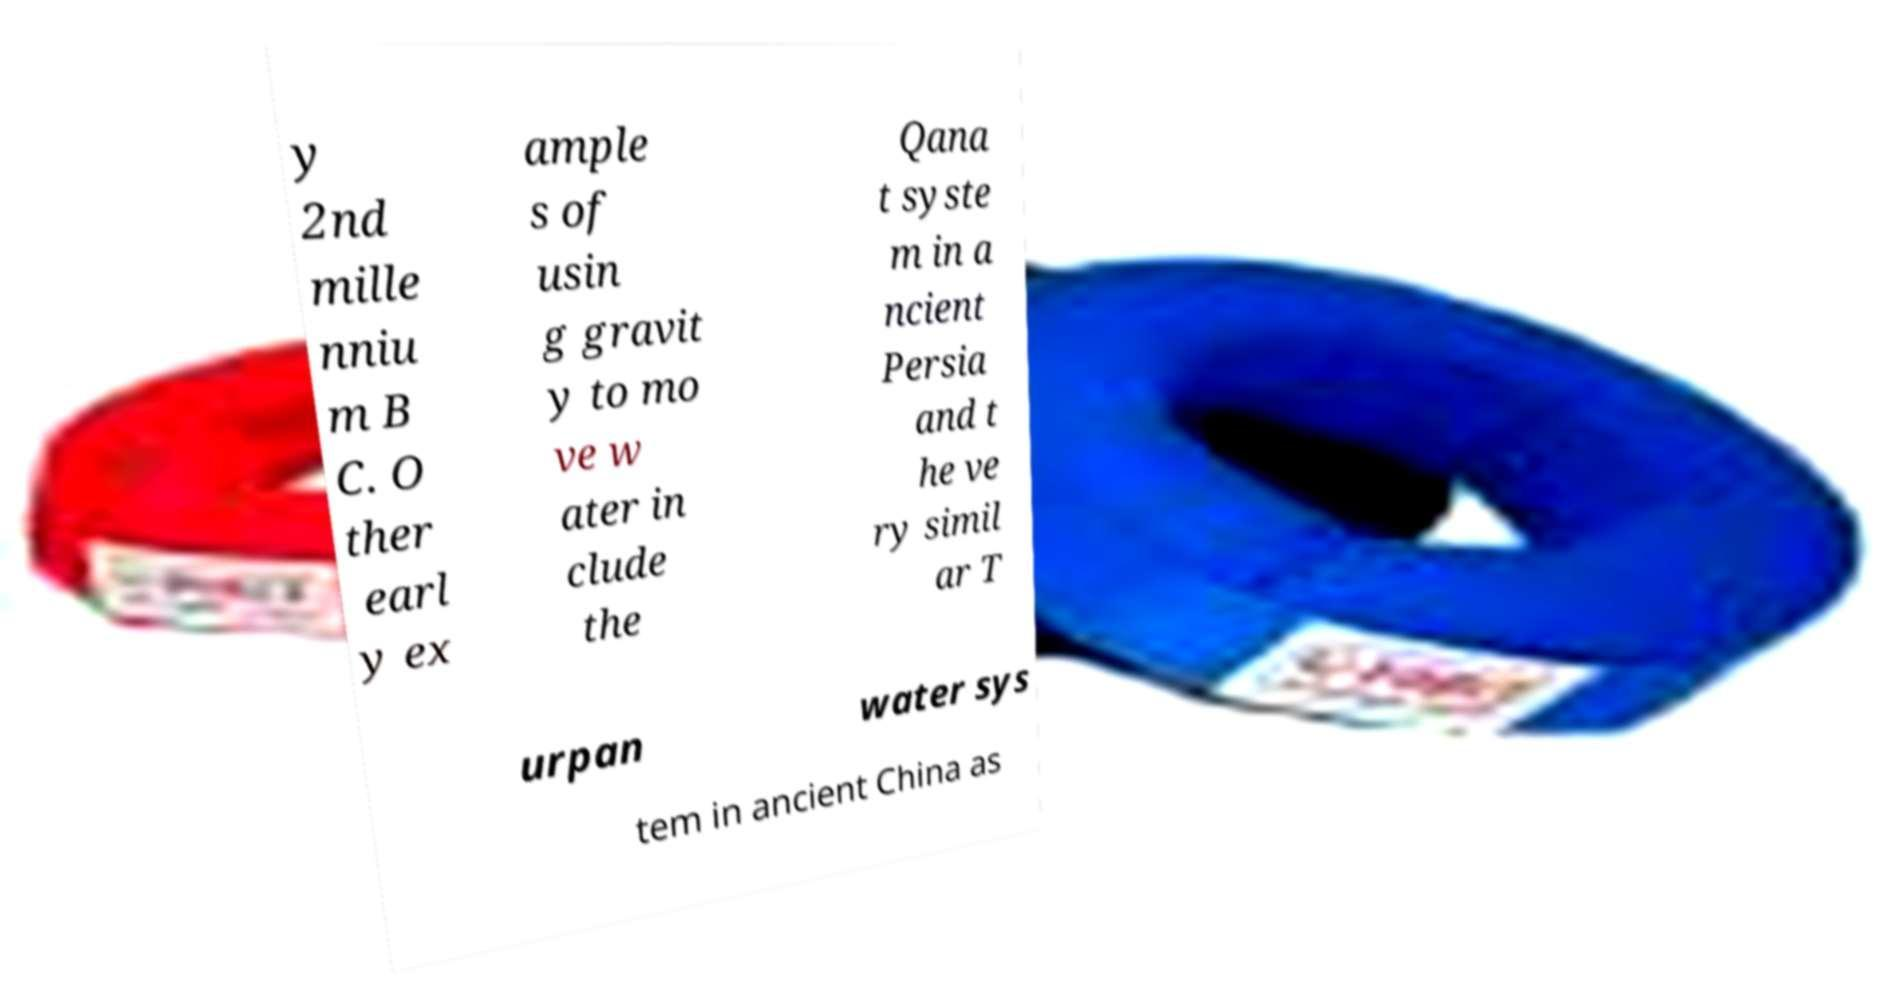Can you read and provide the text displayed in the image?This photo seems to have some interesting text. Can you extract and type it out for me? y 2nd mille nniu m B C. O ther earl y ex ample s of usin g gravit y to mo ve w ater in clude the Qana t syste m in a ncient Persia and t he ve ry simil ar T urpan water sys tem in ancient China as 